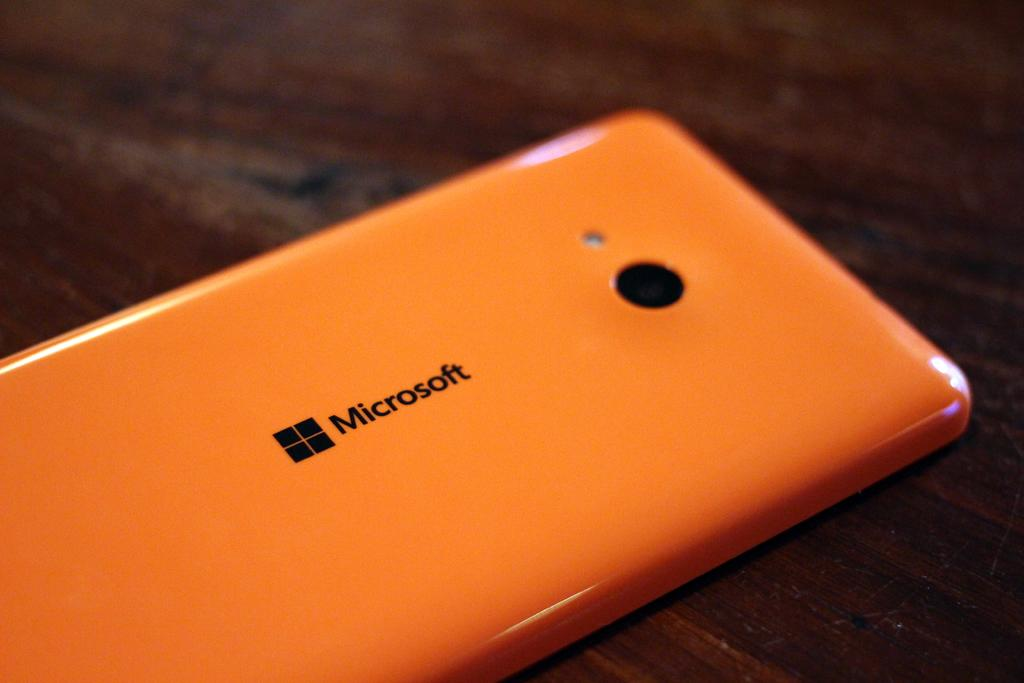Provide a one-sentence caption for the provided image. An orange phone from the brand microsoft is on a wooden surface. 